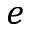Convert formula to latex. <formula><loc_0><loc_0><loc_500><loc_500>e</formula> 